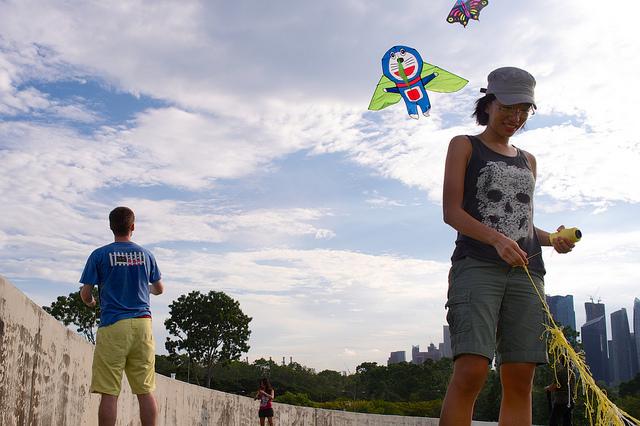Are the people facing the same direction?
Answer briefly. No. What is in the air?
Keep it brief. Kites. What does the girl have on her head?
Quick response, please. Hat. 